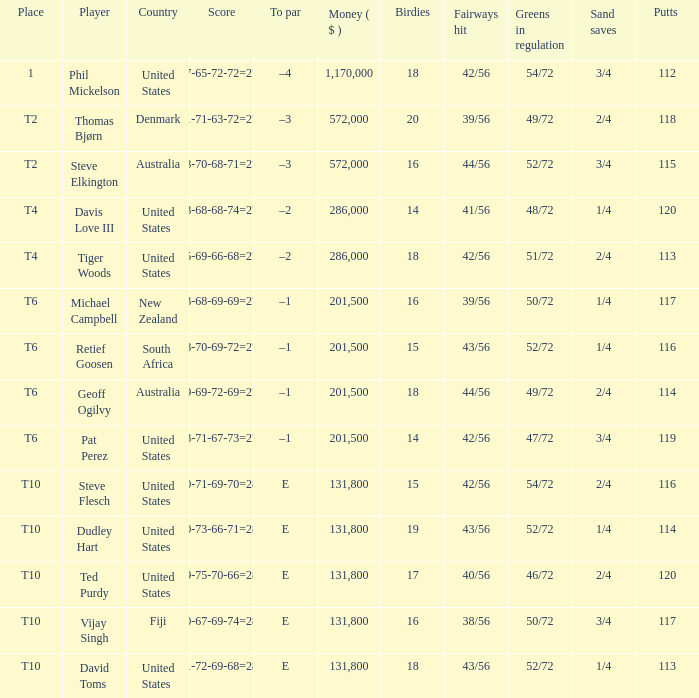What is the largest money for a t4 place, for Tiger Woods? 286000.0. 